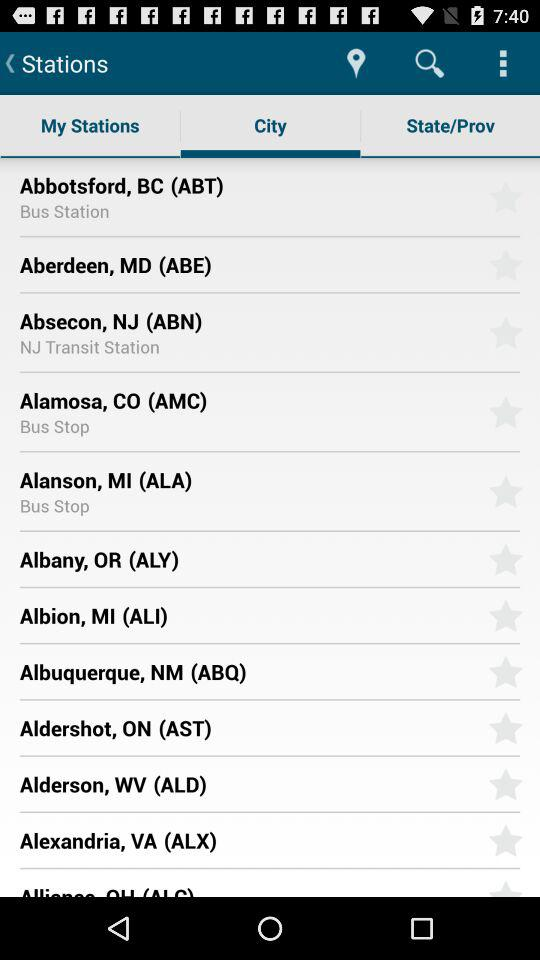What's the city's name for having a transit station? The city's name is Absecon, NJ (ABN). 